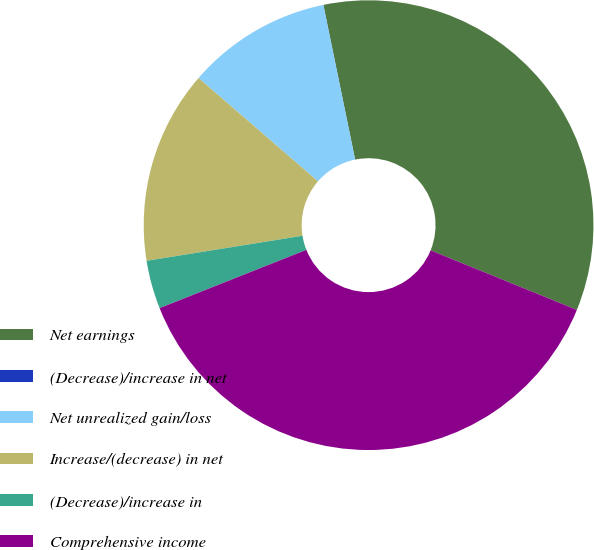Convert chart. <chart><loc_0><loc_0><loc_500><loc_500><pie_chart><fcel>Net earnings<fcel>(Decrease)/increase in net<fcel>Net unrealized gain/loss<fcel>Increase/(decrease) in net<fcel>(Decrease)/increase in<fcel>Comprehensive income<nl><fcel>34.37%<fcel>0.01%<fcel>10.42%<fcel>13.89%<fcel>3.48%<fcel>37.84%<nl></chart> 